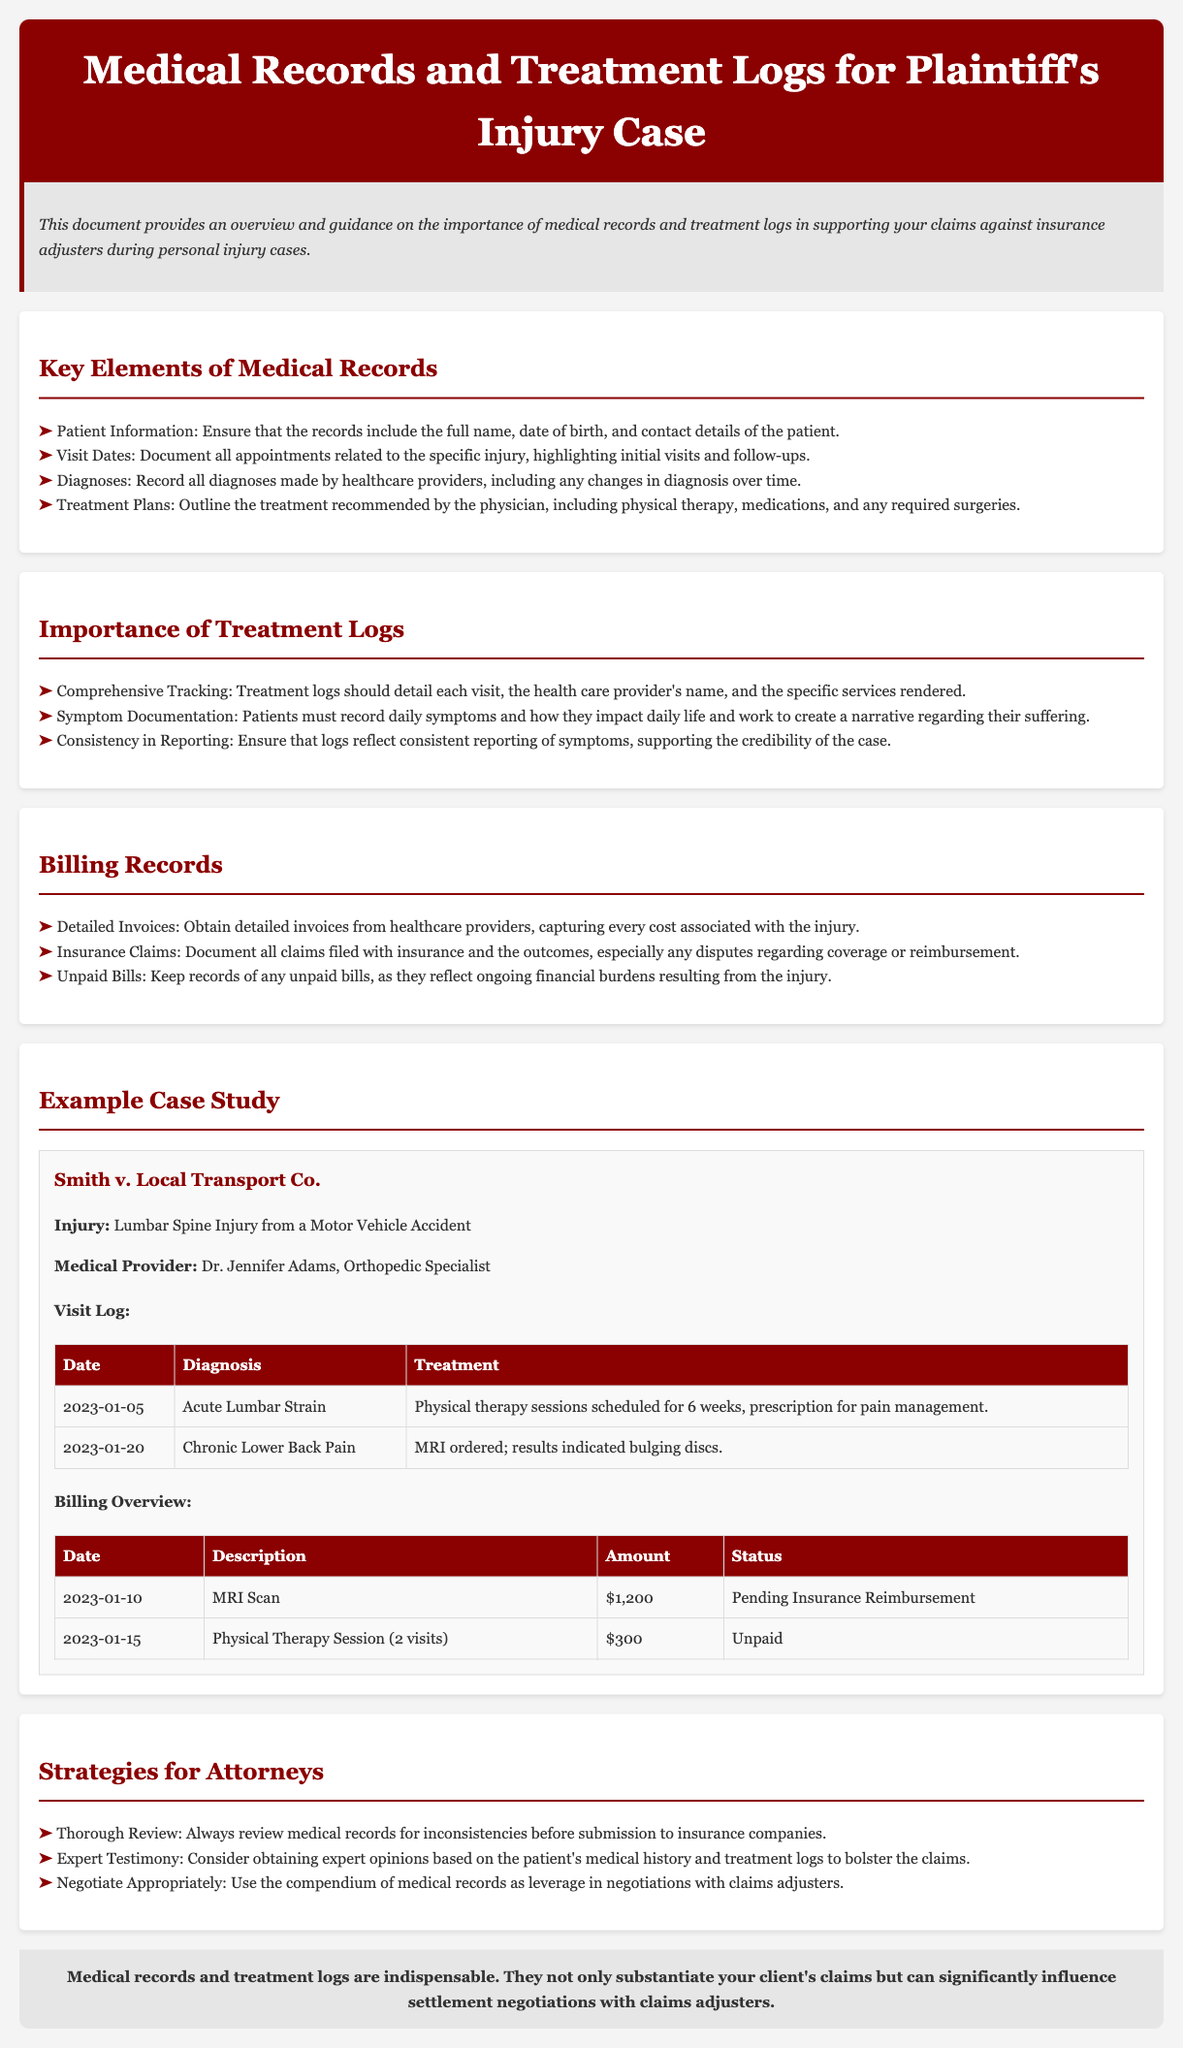What is the title of the document? The title of the document is provided in the header section, indicating its purpose related to medical records and treatment logs for a specific case.
Answer: Medical Records and Treatment Logs for Plaintiff's Injury Case Who is the medical provider in the example case study? The medical provider's name is listed in the case study section, detailing who handled the plaintiff's treatment.
Answer: Dr. Jennifer Adams What was the initial diagnosis on January 5, 2023? The first diagnosis is mentioned in the visit log under the corresponding date, capturing the patient's initial condition.
Answer: Acute Lumbar Strain How many physical therapy sessions were scheduled initially? The treatment details in the visit log outline the planned treatment by the medical provider, specifying the number of sessions.
Answer: 6 weeks What amount is pending for reimbursement for the MRI scan? The billing overview lists specific amounts linked to treatments along with their status, thus indicating amounts awaiting reimbursement.
Answer: $1,200 What is the status of the physical therapy bill on January 15, 2023? The overview of billing records includes descriptions of bills and their payment statuses for clarity on financial obligations.
Answer: Unpaid What is the primary focus of the introduction section? The introduction provides a summary of the document's purpose and the significance of the records for claims against insurance adjusters.
Answer: Importance of medical records and treatment logs What is advised for attorneys when reviewing medical records? Recommendations for attorneys are made in the strategies section, highlighting necessary actions concerning medical records.
Answer: Thorough Review 